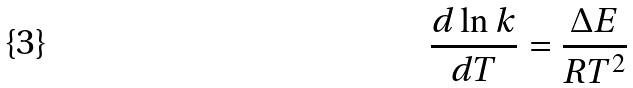Convert formula to latex. <formula><loc_0><loc_0><loc_500><loc_500>\frac { d \ln k } { d T } = \frac { \Delta E } { R T ^ { 2 } }</formula> 